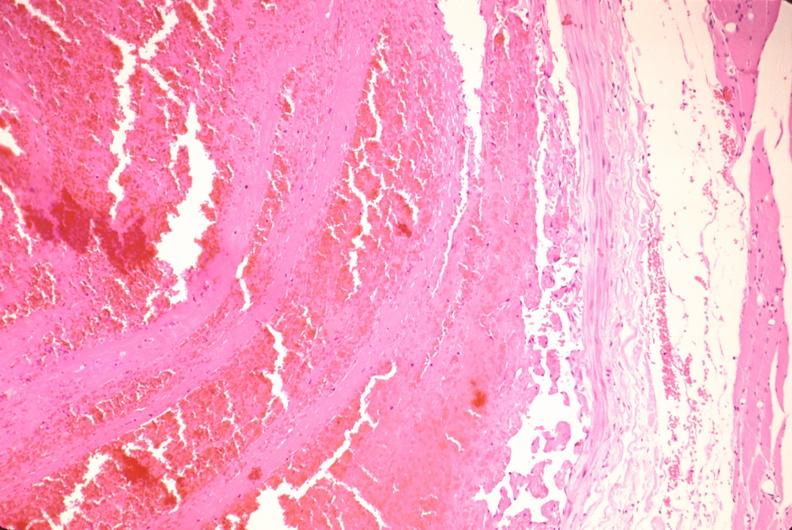does this typical lesion show thrombus in leg vein with early organization?
Answer the question using a single word or phrase. No 